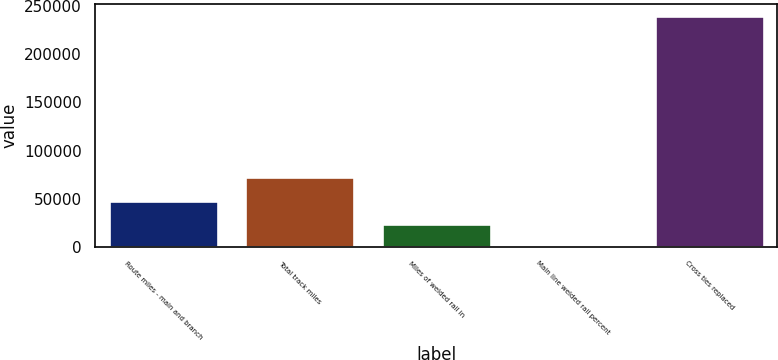Convert chart to OTSL. <chart><loc_0><loc_0><loc_500><loc_500><bar_chart><fcel>Route miles - main and branch<fcel>Total track miles<fcel>Miles of welded rail in<fcel>Main line welded rail percent<fcel>Cross ties replaced<nl><fcel>48057<fcel>72046.5<fcel>24067.5<fcel>78<fcel>239973<nl></chart> 